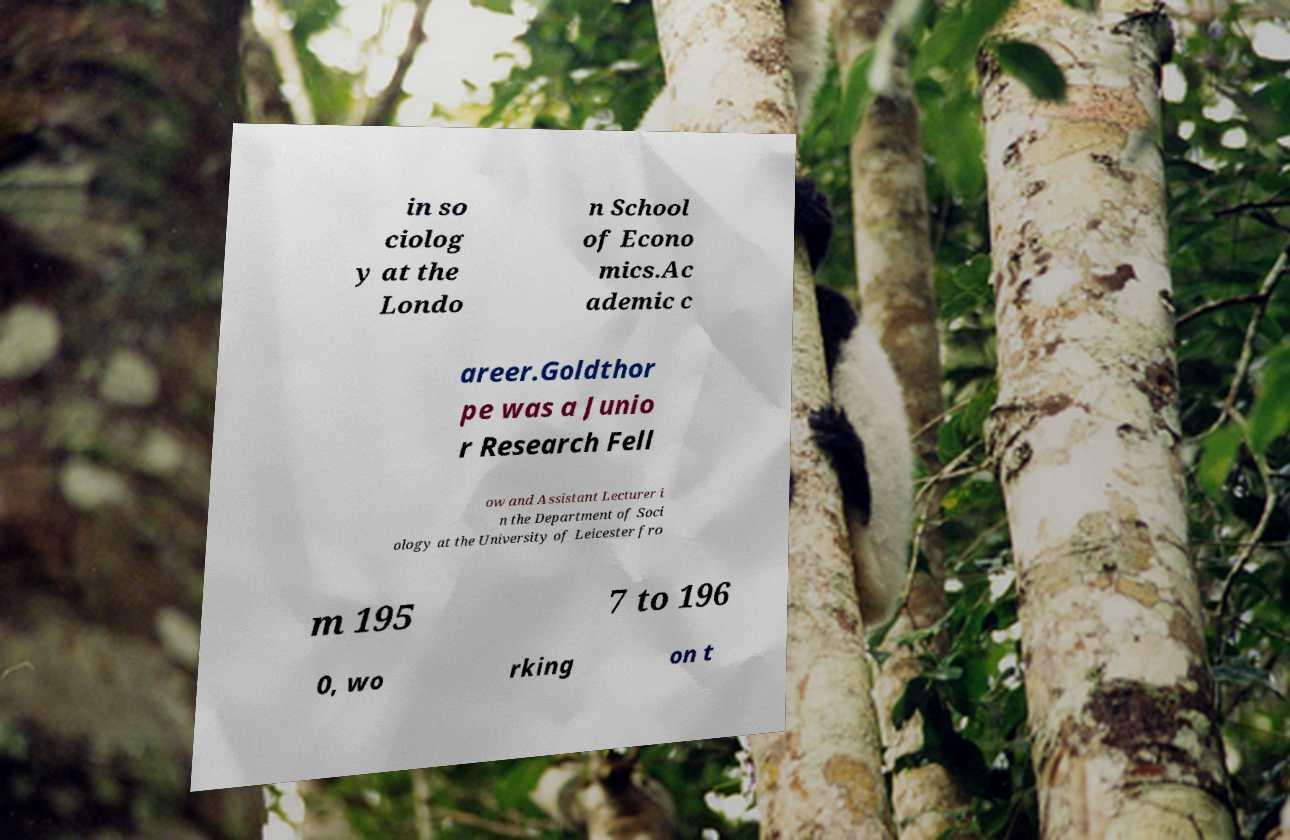Please identify and transcribe the text found in this image. in so ciolog y at the Londo n School of Econo mics.Ac ademic c areer.Goldthor pe was a Junio r Research Fell ow and Assistant Lecturer i n the Department of Soci ology at the University of Leicester fro m 195 7 to 196 0, wo rking on t 